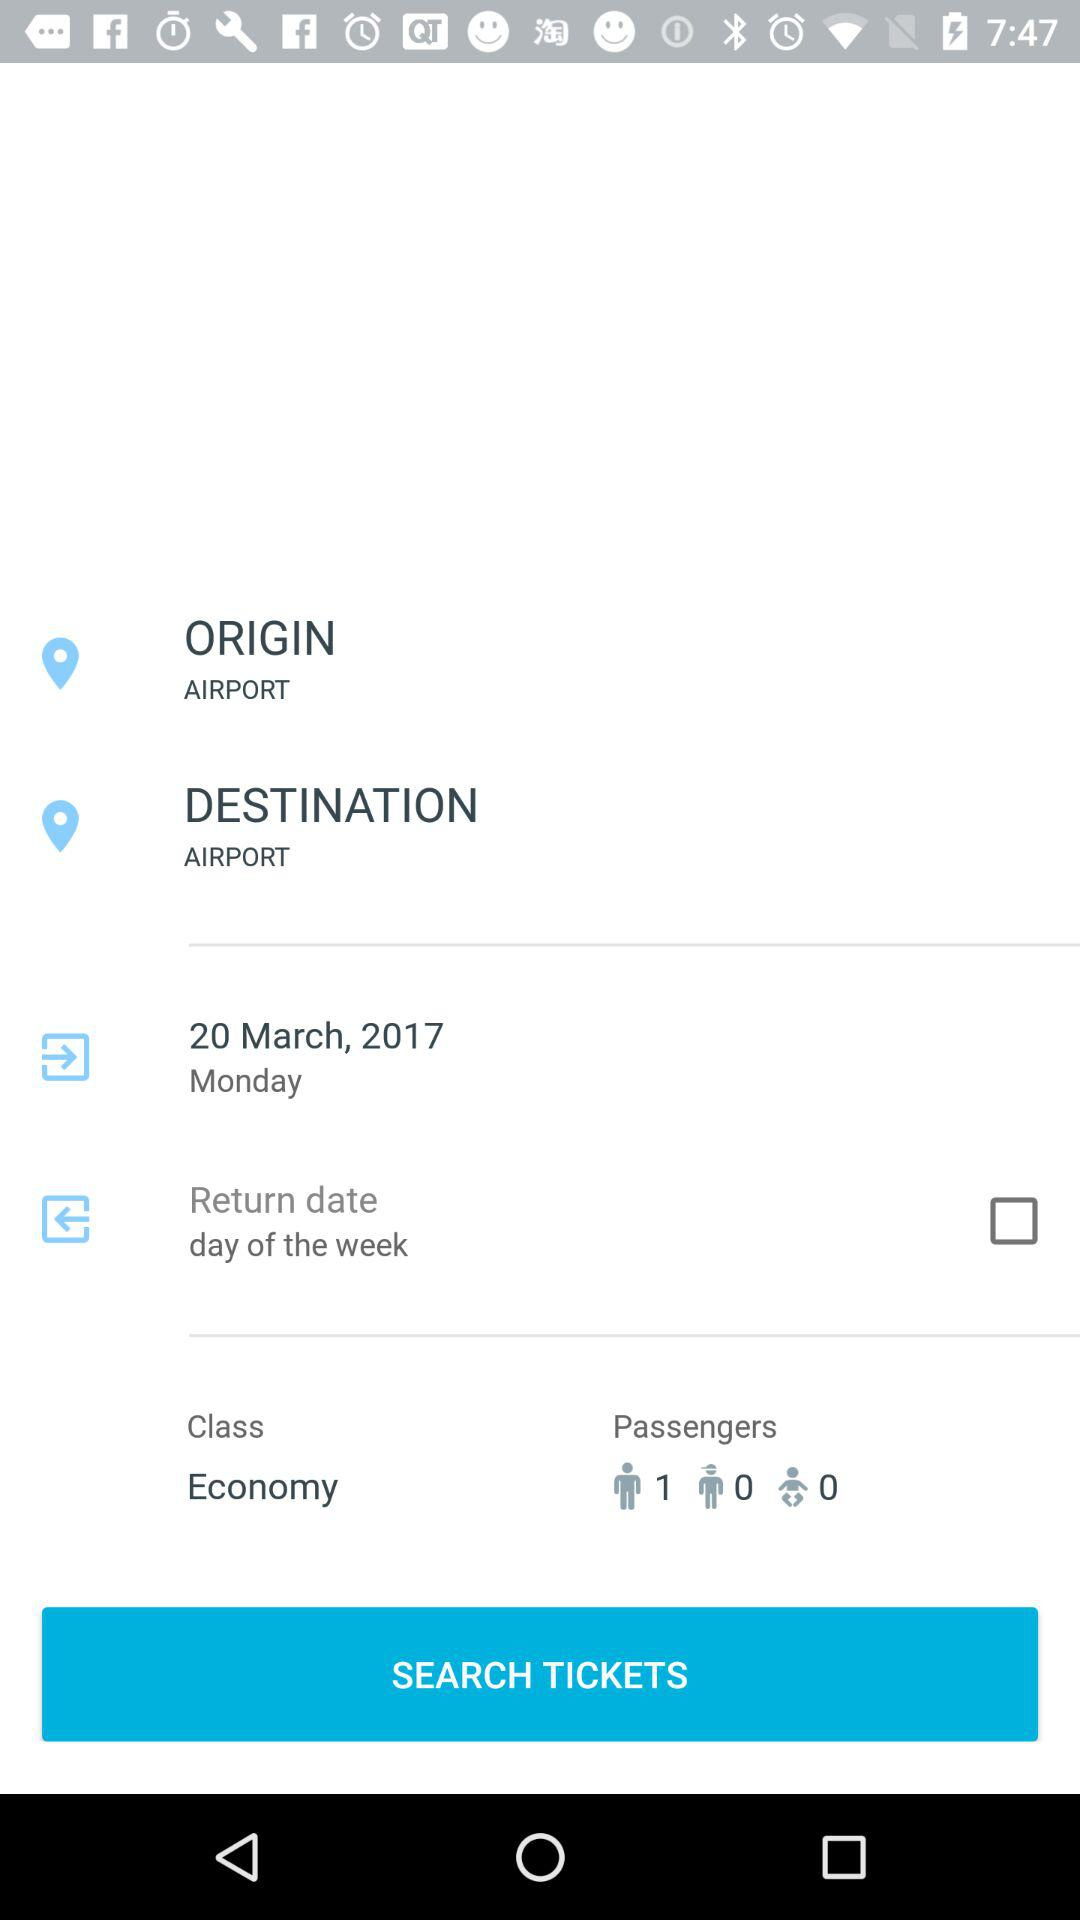How many passengers are there on this flight?
Answer the question using a single word or phrase. 1 